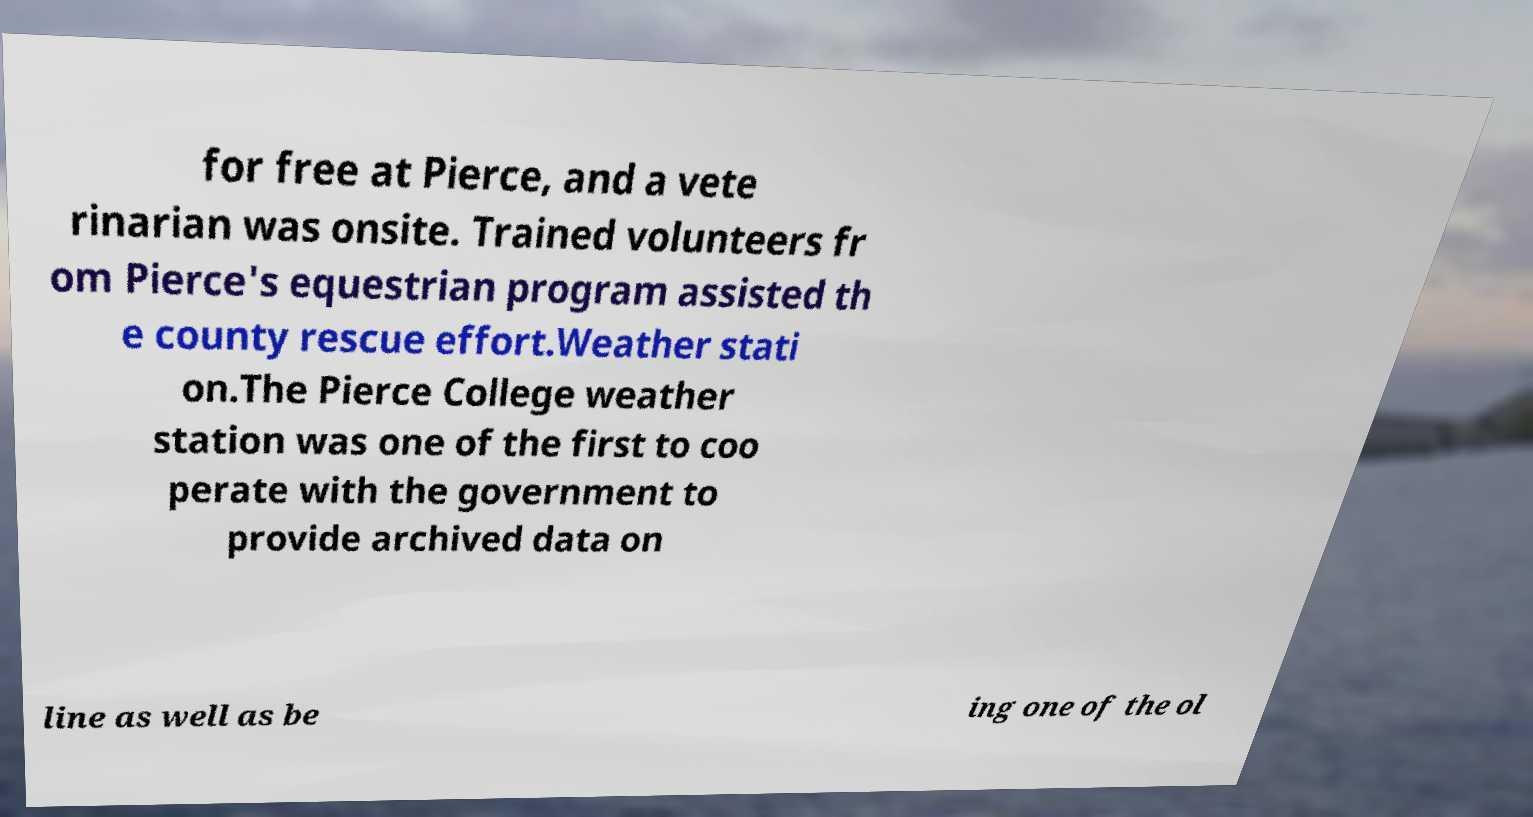Can you accurately transcribe the text from the provided image for me? for free at Pierce, and a vete rinarian was onsite. Trained volunteers fr om Pierce's equestrian program assisted th e county rescue effort.Weather stati on.The Pierce College weather station was one of the first to coo perate with the government to provide archived data on line as well as be ing one of the ol 